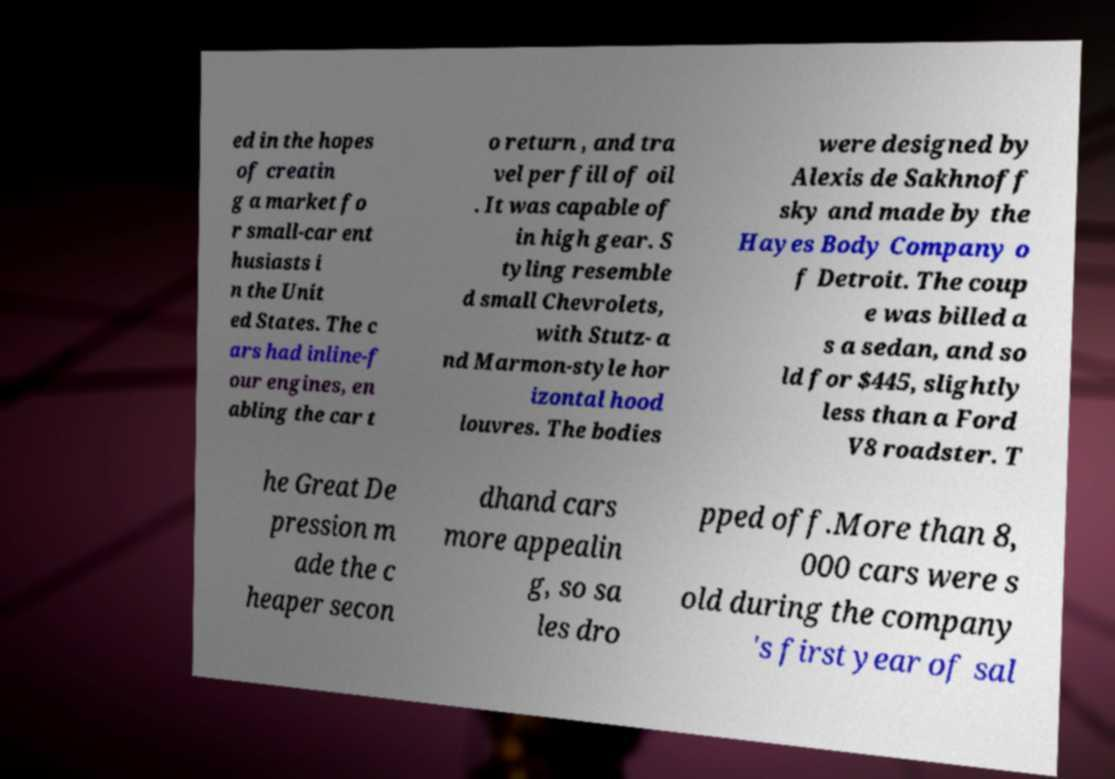I need the written content from this picture converted into text. Can you do that? ed in the hopes of creatin g a market fo r small-car ent husiasts i n the Unit ed States. The c ars had inline-f our engines, en abling the car t o return , and tra vel per fill of oil . It was capable of in high gear. S tyling resemble d small Chevrolets, with Stutz- a nd Marmon-style hor izontal hood louvres. The bodies were designed by Alexis de Sakhnoff sky and made by the Hayes Body Company o f Detroit. The coup e was billed a s a sedan, and so ld for $445, slightly less than a Ford V8 roadster. T he Great De pression m ade the c heaper secon dhand cars more appealin g, so sa les dro pped off.More than 8, 000 cars were s old during the company 's first year of sal 